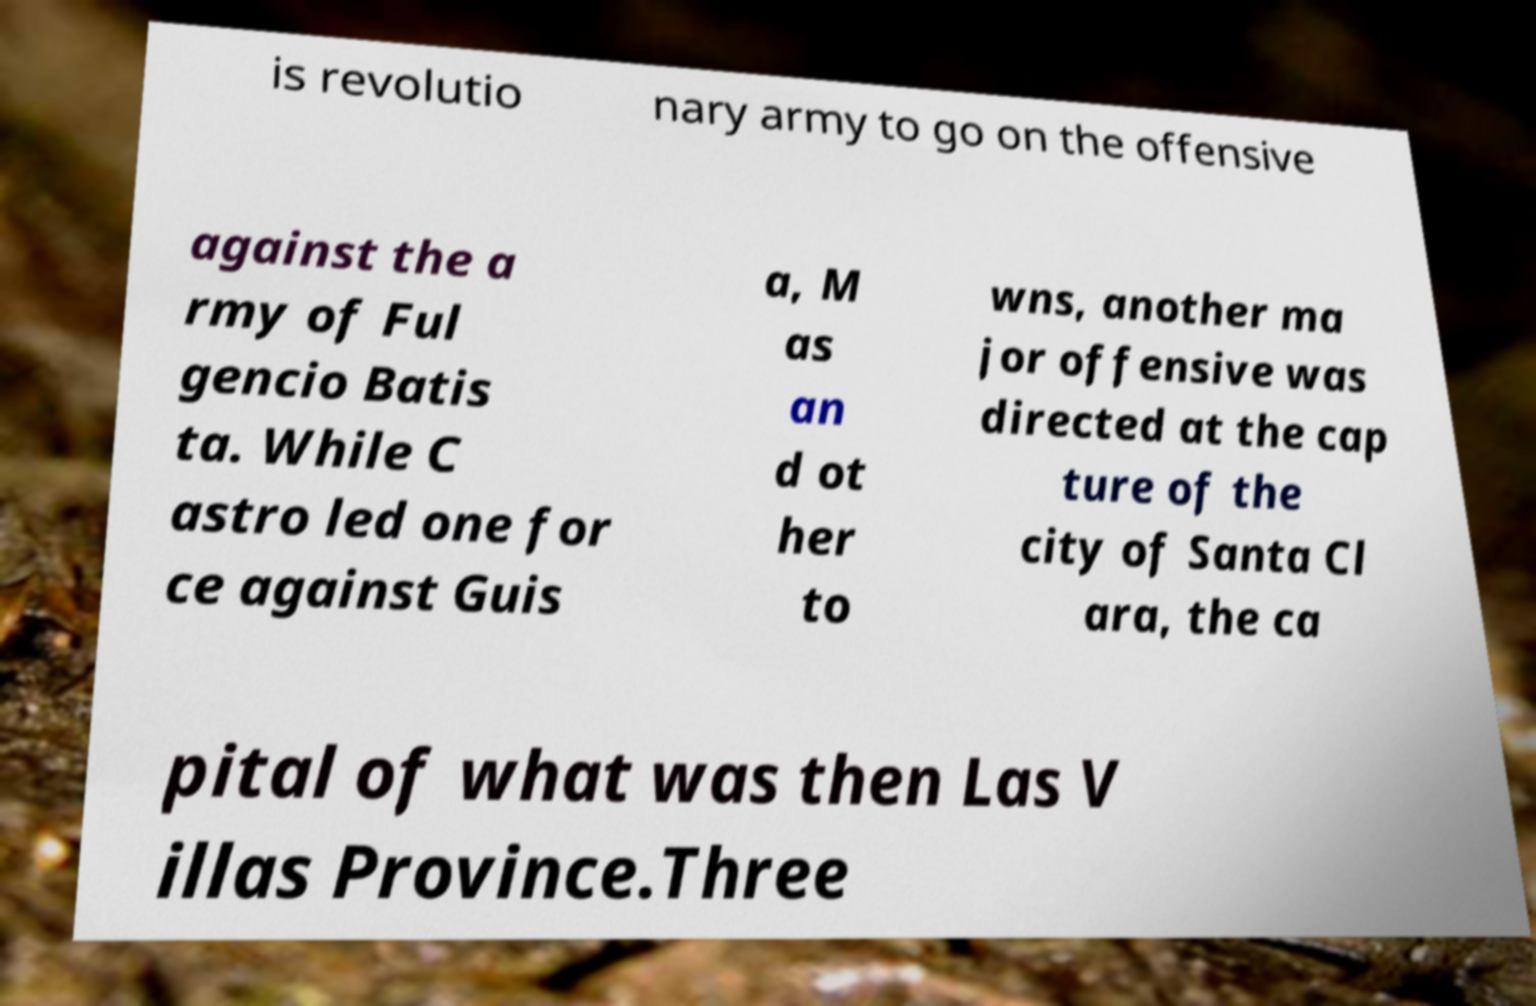Can you accurately transcribe the text from the provided image for me? is revolutio nary army to go on the offensive against the a rmy of Ful gencio Batis ta. While C astro led one for ce against Guis a, M as an d ot her to wns, another ma jor offensive was directed at the cap ture of the city of Santa Cl ara, the ca pital of what was then Las V illas Province.Three 